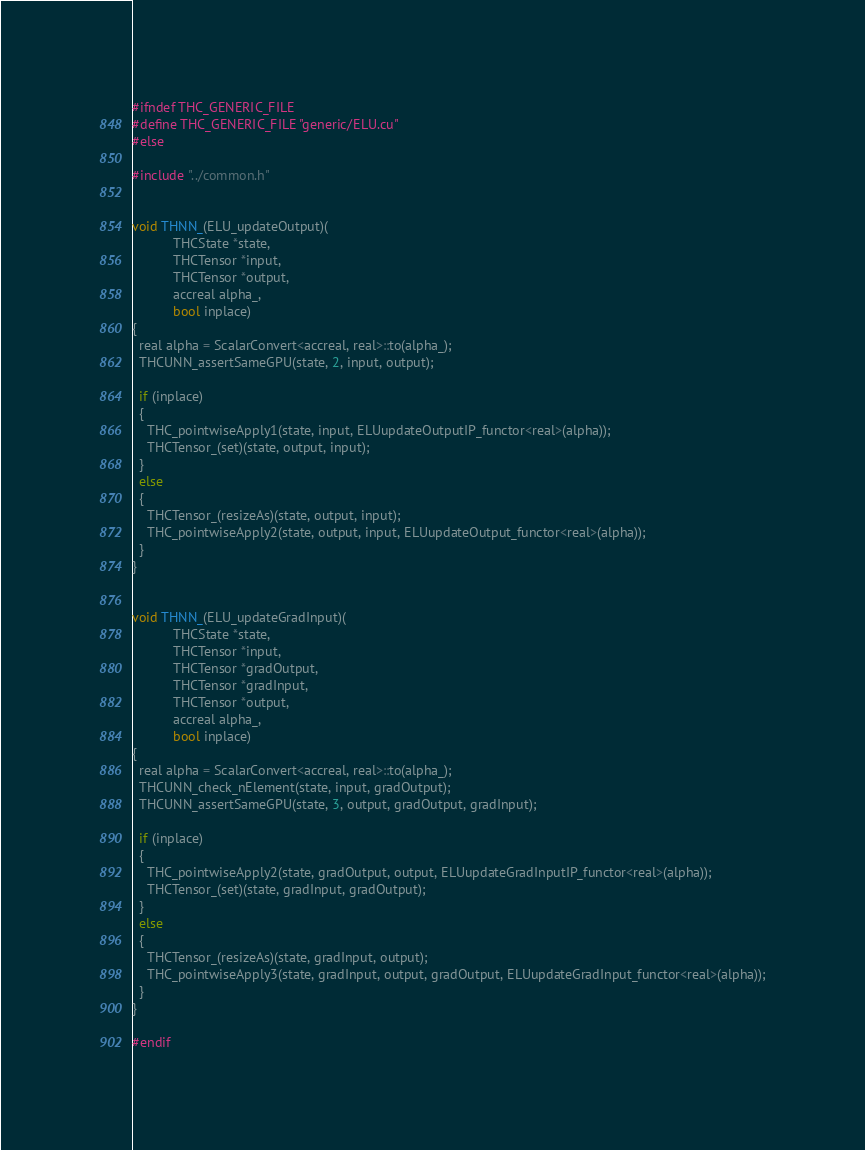Convert code to text. <code><loc_0><loc_0><loc_500><loc_500><_Cuda_>#ifndef THC_GENERIC_FILE
#define THC_GENERIC_FILE "generic/ELU.cu"
#else

#include "../common.h"


void THNN_(ELU_updateOutput)(
           THCState *state,
           THCTensor *input,
           THCTensor *output,
           accreal alpha_,
           bool inplace)
{
  real alpha = ScalarConvert<accreal, real>::to(alpha_);
  THCUNN_assertSameGPU(state, 2, input, output);

  if (inplace)
  {
    THC_pointwiseApply1(state, input, ELUupdateOutputIP_functor<real>(alpha));
    THCTensor_(set)(state, output, input);
  }
  else
  {
    THCTensor_(resizeAs)(state, output, input);
    THC_pointwiseApply2(state, output, input, ELUupdateOutput_functor<real>(alpha));
  }
}


void THNN_(ELU_updateGradInput)(
           THCState *state,
           THCTensor *input,
           THCTensor *gradOutput,
           THCTensor *gradInput,
           THCTensor *output,
           accreal alpha_,
           bool inplace)
{
  real alpha = ScalarConvert<accreal, real>::to(alpha_);
  THCUNN_check_nElement(state, input, gradOutput);
  THCUNN_assertSameGPU(state, 3, output, gradOutput, gradInput);

  if (inplace)
  {
    THC_pointwiseApply2(state, gradOutput, output, ELUupdateGradInputIP_functor<real>(alpha));
    THCTensor_(set)(state, gradInput, gradOutput);
  }
  else
  {
    THCTensor_(resizeAs)(state, gradInput, output);
    THC_pointwiseApply3(state, gradInput, output, gradOutput, ELUupdateGradInput_functor<real>(alpha));
  }
}

#endif
</code> 